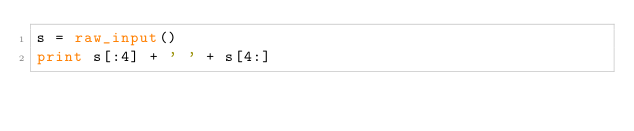Convert code to text. <code><loc_0><loc_0><loc_500><loc_500><_Python_>s = raw_input()
print s[:4] + ' ' + s[4:]
</code> 